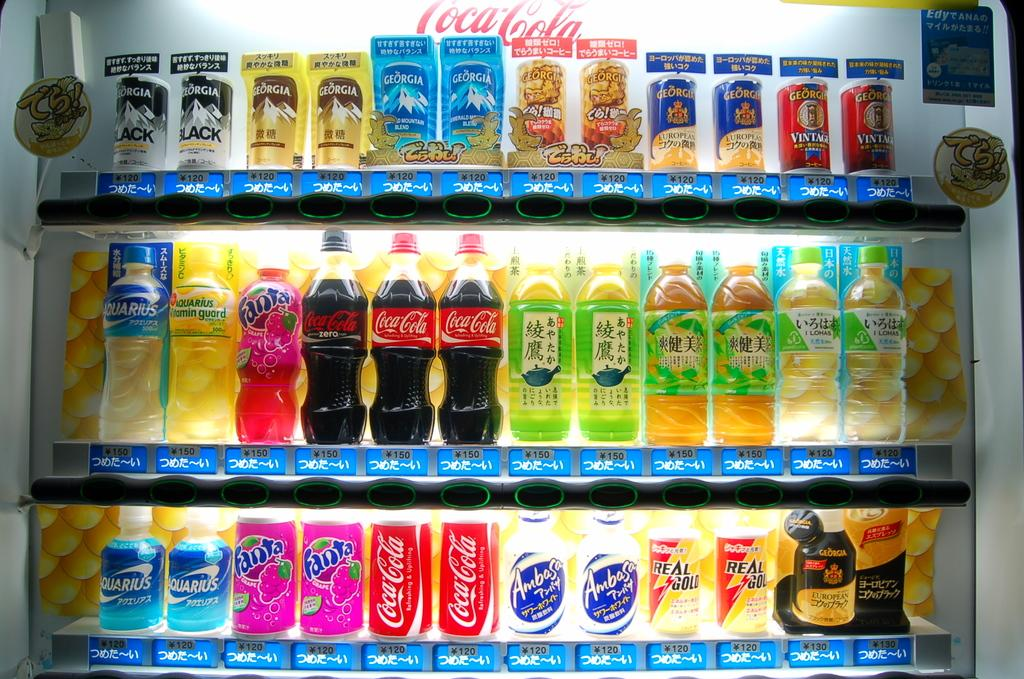<image>
Offer a succinct explanation of the picture presented. A fridge display includes a pink bottle of Fanta Grape. 